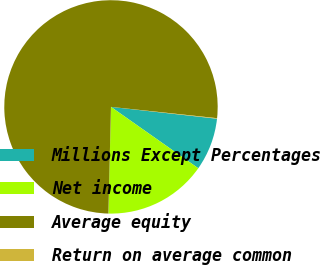Convert chart. <chart><loc_0><loc_0><loc_500><loc_500><pie_chart><fcel>Millions Except Percentages<fcel>Net income<fcel>Average equity<fcel>Return on average common<nl><fcel>7.98%<fcel>15.64%<fcel>76.29%<fcel>0.08%<nl></chart> 